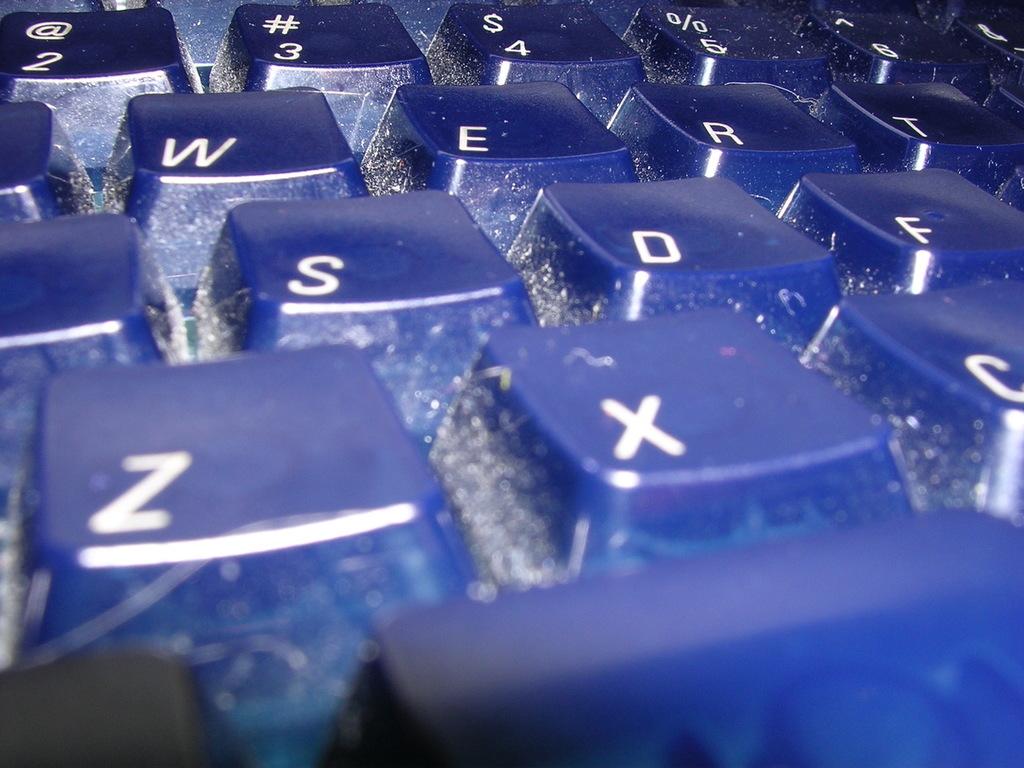What letter is the largest?
Provide a succinct answer. Z. 